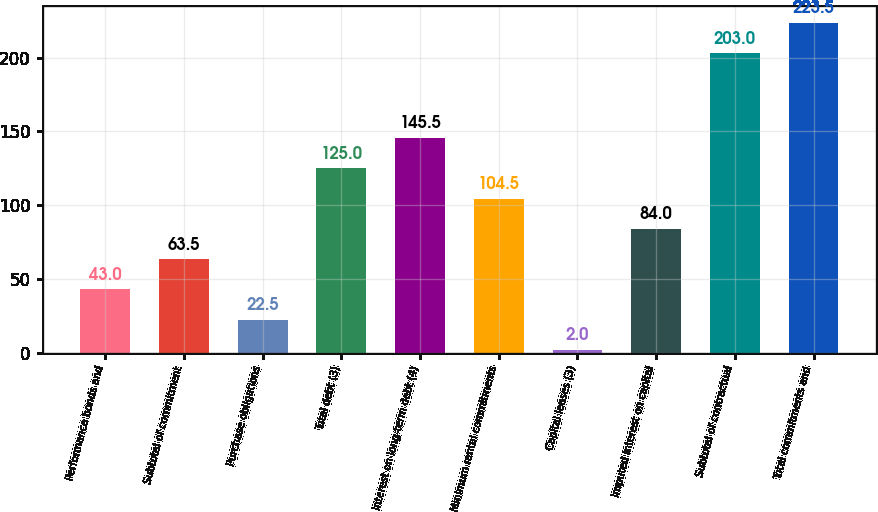Convert chart. <chart><loc_0><loc_0><loc_500><loc_500><bar_chart><fcel>Performance bonds and<fcel>Subtotal of commitment<fcel>Purchase obligations<fcel>Total debt (3)<fcel>Interest on long-term debt (4)<fcel>Minimum rental commitments<fcel>Capital leases (3)<fcel>Imputed interest on capital<fcel>Subtotal of contractual<fcel>Total commitments and<nl><fcel>43<fcel>63.5<fcel>22.5<fcel>125<fcel>145.5<fcel>104.5<fcel>2<fcel>84<fcel>203<fcel>223.5<nl></chart> 